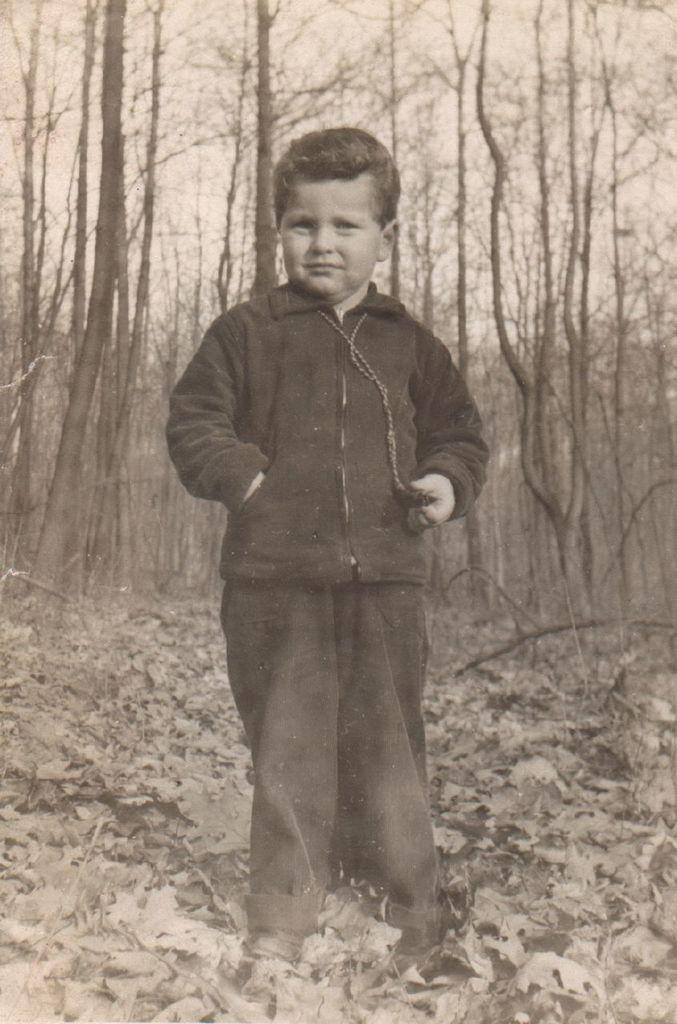What is the color scheme of the image? The image is in black and white. Who is the main subject in the image? There is a kid in the center of the image. What is the kid wearing? The kid is wearing a jacket and trousers. What can be seen at the bottom of the image? There are dried leaves at the bottom of the image. What is visible in the background of the image? There are trees and the sky in the background of the image. Where is the prison located in the image? There is no prison present in the image. Is the girl in the image wearing a dress? There is no girl present in the image, only a kid wearing a jacket and trousers. 